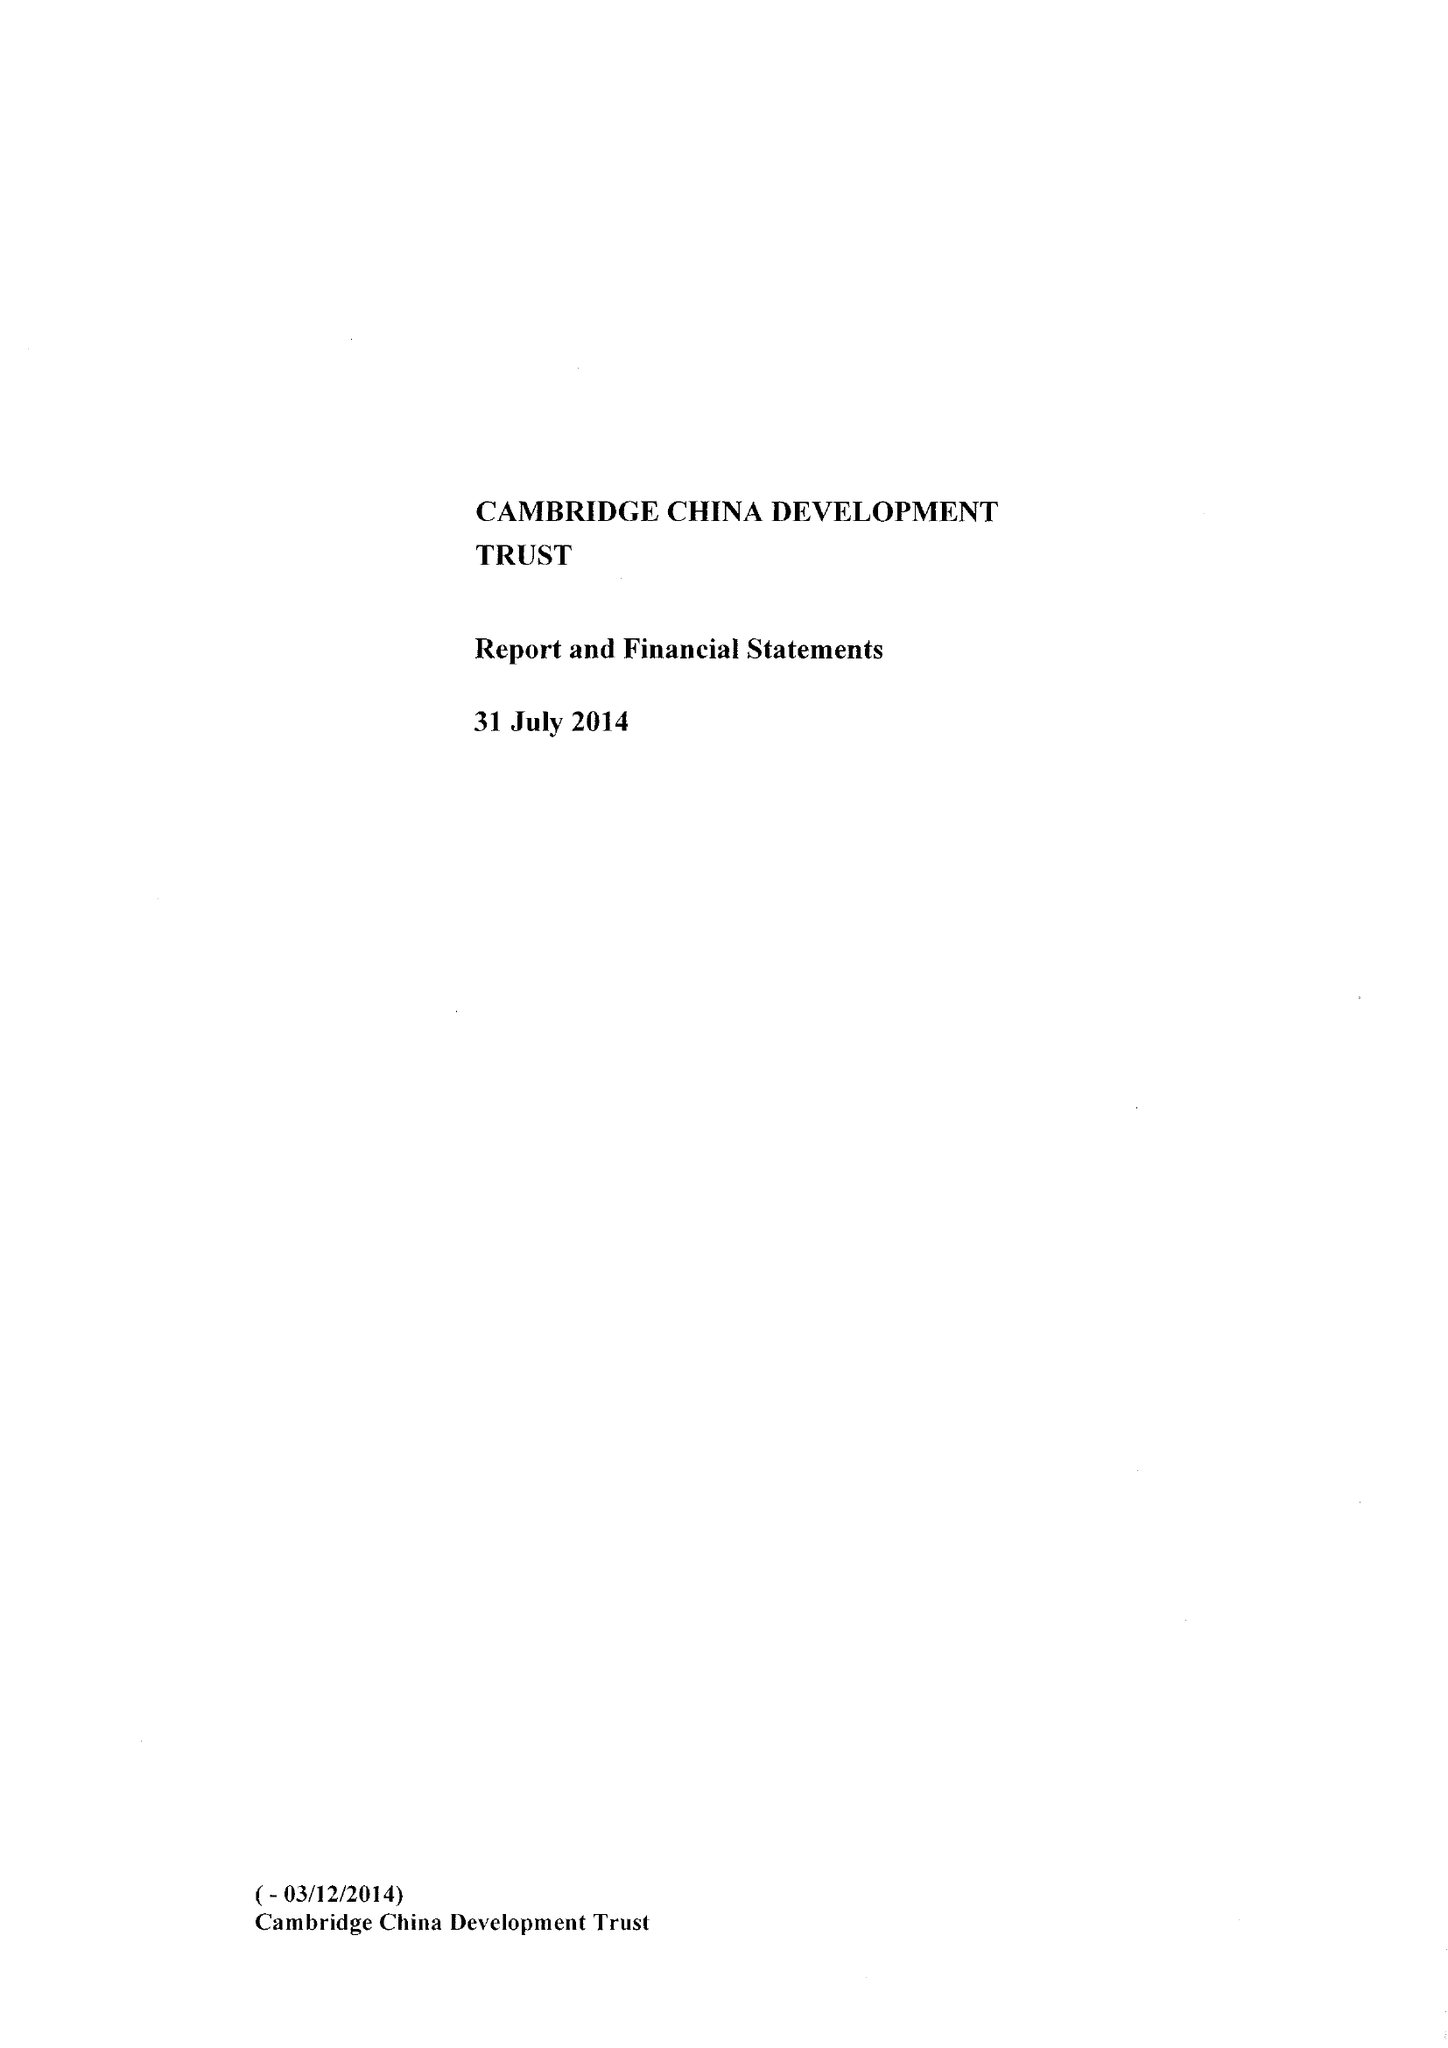What is the value for the report_date?
Answer the question using a single word or phrase. 2014-07-31 